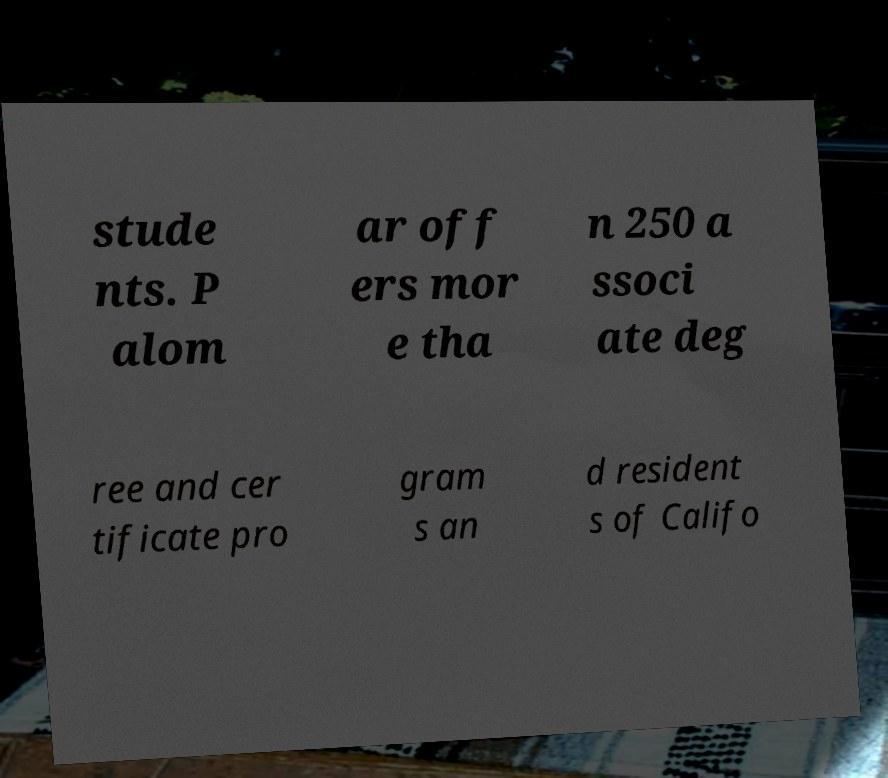Please read and relay the text visible in this image. What does it say? stude nts. P alom ar off ers mor e tha n 250 a ssoci ate deg ree and cer tificate pro gram s an d resident s of Califo 